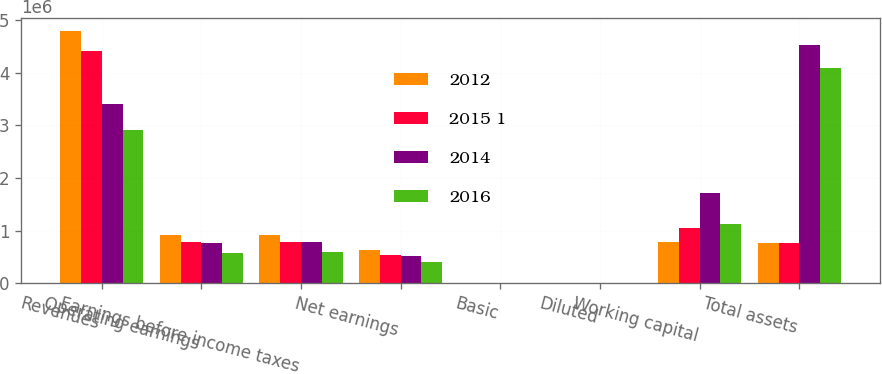<chart> <loc_0><loc_0><loc_500><loc_500><stacked_bar_chart><ecel><fcel>Revenues<fcel>Operating earnings<fcel>Earnings before income taxes<fcel>Net earnings<fcel>Basic<fcel>Diluted<fcel>Working capital<fcel>Total assets<nl><fcel>2012<fcel>4.79647e+06<fcel>911013<fcel>918434<fcel>636484<fcel>1.88<fcel>1.85<fcel>773960<fcel>768522<nl><fcel>2015 1<fcel>4.42527e+06<fcel>781136<fcel>781380<fcel>539362<fcel>1.57<fcel>1.54<fcel>1.04997e+06<fcel>768522<nl><fcel>2014<fcel>3.4027e+06<fcel>763084<fcel>774174<fcel>525433<fcel>1.54<fcel>1.5<fcel>1.71447e+06<fcel>4.53056e+06<nl><fcel>2016<fcel>2.91075e+06<fcel>576012<fcel>588054<fcel>398354<fcel>1.16<fcel>1.13<fcel>1.12128e+06<fcel>4.09836e+06<nl></chart> 